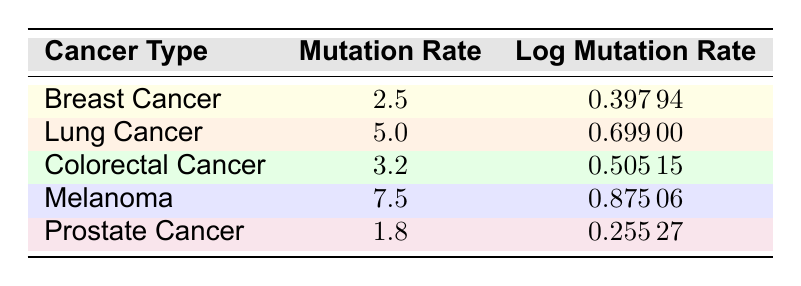What is the mutation rate for Lung Cancer? The mutation rate for Lung Cancer is explicitly listed in the table under the "Mutation Rate" column.
Answer: 5.0 Which cancer type has the highest logarithmic mutation rate? In the "Log Mutation Rate" column, the highest value is 0.87506 for Melanoma.
Answer: Melanoma What is the difference in mutation rates between Melanoma and Colorectal Cancer? The mutation rate for Melanoma is 7.5 and for Colorectal Cancer is 3.2. Therefore, the difference is calculated as 7.5 - 3.2 = 4.3.
Answer: 4.3 Is the mutation rate for Prostate Cancer greater than 2.0? The mutation rate for Prostate Cancer is 1.8, which is less than 2.0. Therefore, the answer is no.
Answer: No What is the average mutation rate across all cancer types listed in the table? The mutation rates are 2.5, 5.0, 3.2, 7.5, and 1.8. Adding them gives 20.0. Dividing by the number of cancer types (5) results in an average of 20.0 / 5 = 4.0.
Answer: 4.0 Which cancer type has a mutation rate closest to 3.0? Looking at the mutation rates, Colorectal Cancer has a mutation rate of 3.2, which is the closest to 3.0 compared to the others.
Answer: Colorectal Cancer Is the logarithmic mutation rate for Breast Cancer less than that for Colorectal Cancer? The logarithmic mutation rate for Breast Cancer is 0.39794 and for Colorectal Cancer is 0.50515. Since 0.39794 is less than 0.50515, the answer is yes.
Answer: Yes What is the sum of the logarithmic mutation rates for Breast Cancer and Lung Cancer? The logarithmic mutation rates are 0.39794 for Breast Cancer and 0.69900 for Lung Cancer. The sum is calculated as 0.39794 + 0.69900 = 1.09694.
Answer: 1.09694 